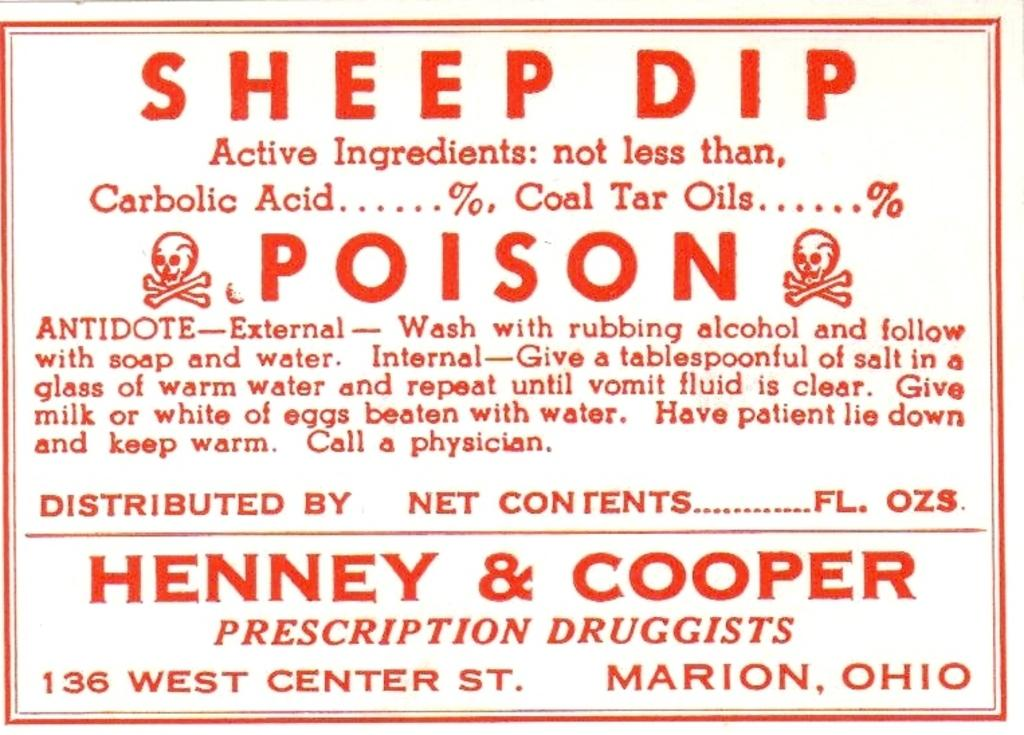<image>
Write a terse but informative summary of the picture. A white sign with red text gives instructions for contact with the poison sheep dip. 